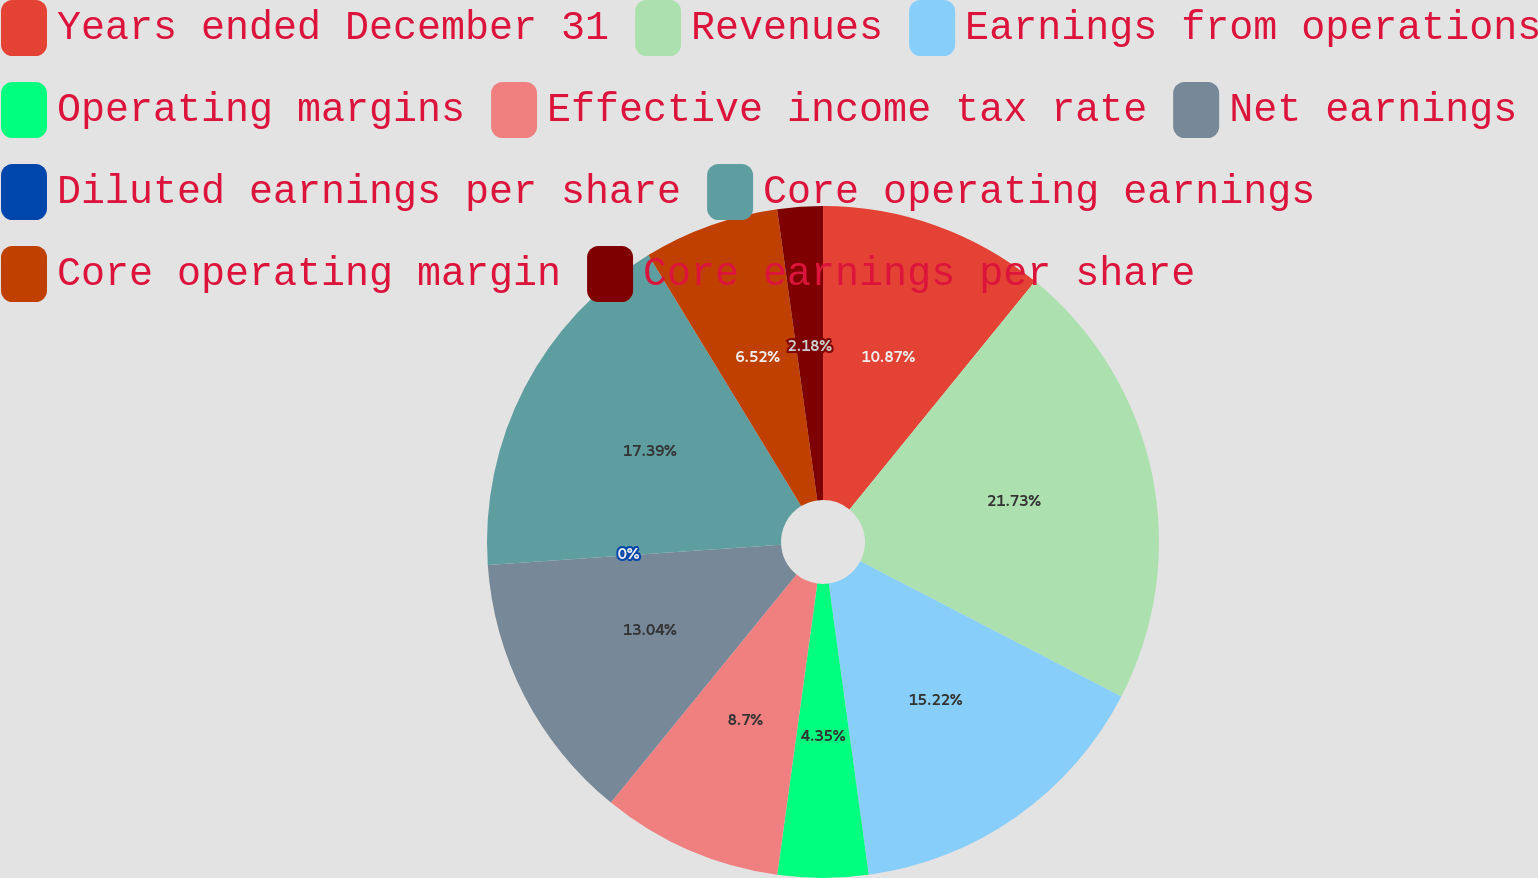Convert chart to OTSL. <chart><loc_0><loc_0><loc_500><loc_500><pie_chart><fcel>Years ended December 31<fcel>Revenues<fcel>Earnings from operations<fcel>Operating margins<fcel>Effective income tax rate<fcel>Net earnings<fcel>Diluted earnings per share<fcel>Core operating earnings<fcel>Core operating margin<fcel>Core earnings per share<nl><fcel>10.87%<fcel>21.74%<fcel>15.22%<fcel>4.35%<fcel>8.7%<fcel>13.04%<fcel>0.0%<fcel>17.39%<fcel>6.52%<fcel>2.18%<nl></chart> 